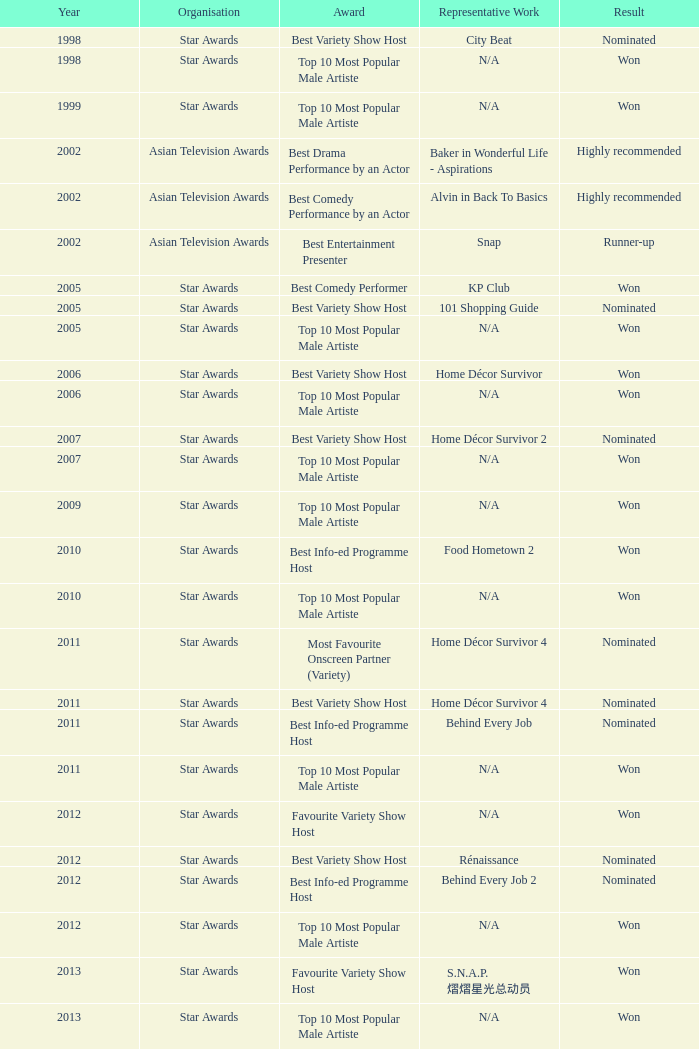Which establishment in 2011 was nominated and garnered the accolade for the leading information-education programme anchor? Star Awards. 